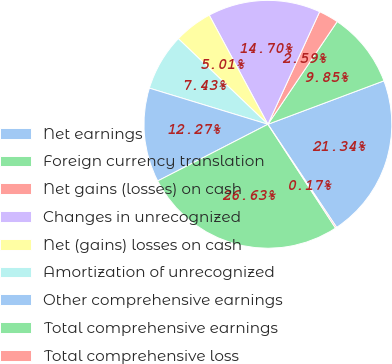Convert chart. <chart><loc_0><loc_0><loc_500><loc_500><pie_chart><fcel>Net earnings<fcel>Foreign currency translation<fcel>Net gains (losses) on cash<fcel>Changes in unrecognized<fcel>Net (gains) losses on cash<fcel>Amortization of unrecognized<fcel>Other comprehensive earnings<fcel>Total comprehensive earnings<fcel>Total comprehensive loss<nl><fcel>21.34%<fcel>9.85%<fcel>2.59%<fcel>14.7%<fcel>5.01%<fcel>7.43%<fcel>12.27%<fcel>26.63%<fcel>0.17%<nl></chart> 